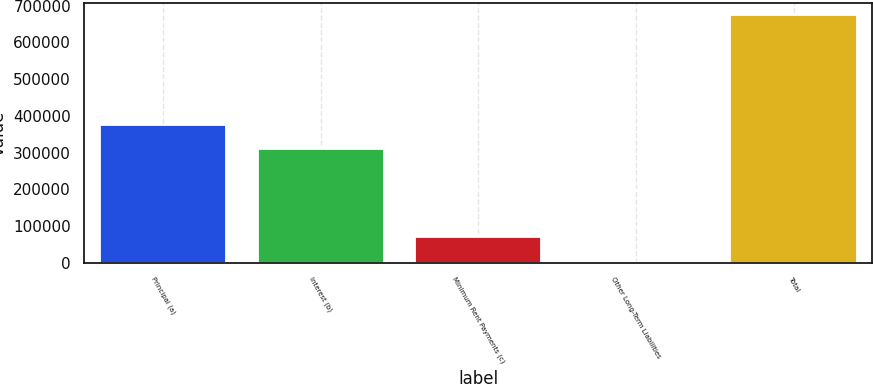Convert chart to OTSL. <chart><loc_0><loc_0><loc_500><loc_500><bar_chart><fcel>Principal (a)<fcel>Interest (b)<fcel>Minimum Rent Payments (c)<fcel>Other Long-Term Liabilities<fcel>Total<nl><fcel>376192<fcel>309043<fcel>68825.5<fcel>1677<fcel>673162<nl></chart> 